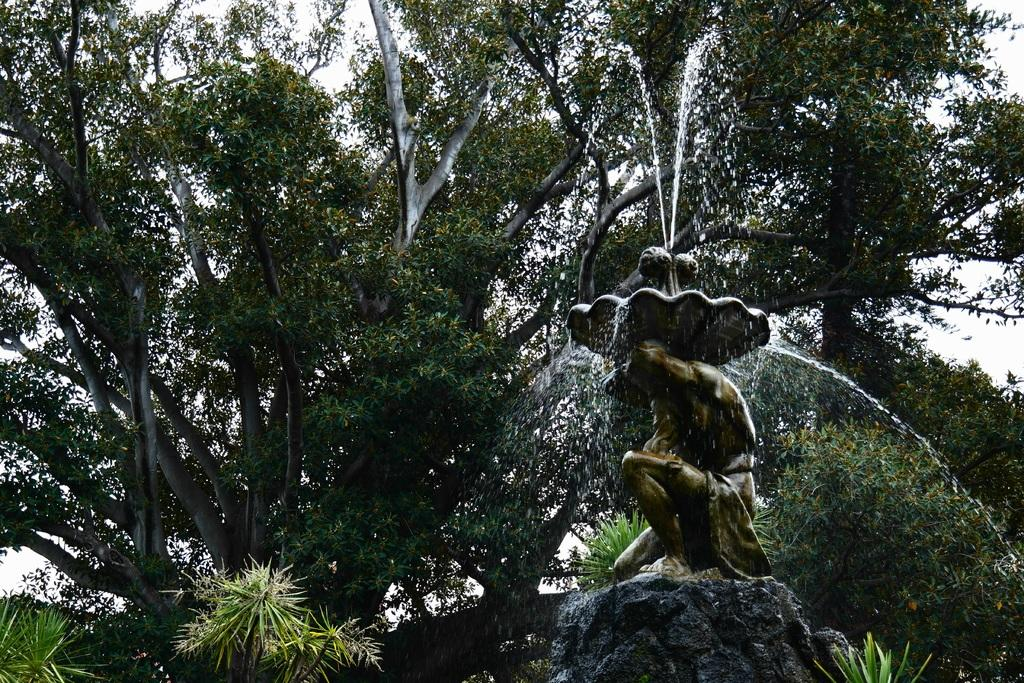What is located on the right side of the image? There is a fountain on the right side of the image. What can be seen in the surroundings of the image? There is greenery around the area of the image. What type of hat is being worn by the fountain in the image? There is no hat present in the image, as the main subject is a fountain. 